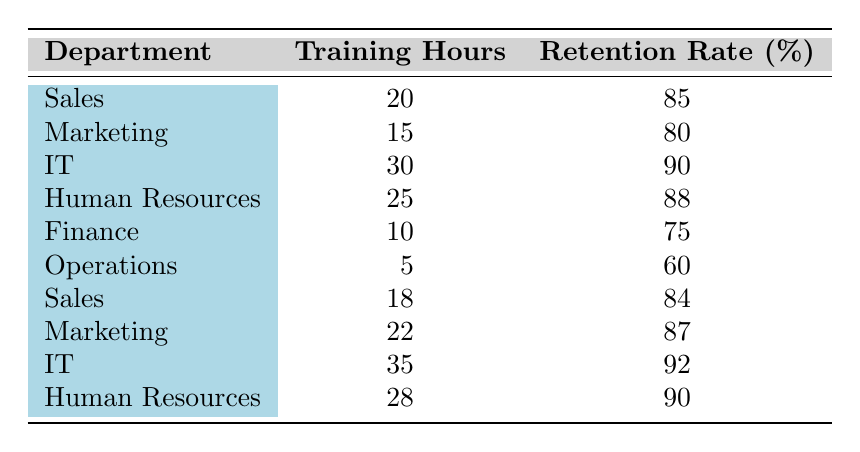What is the retention rate for the IT department? The retention rate for the IT department is listed in the table, where two entries show 90% and 92%. Since both apply to different training hours, the highest is chosen.
Answer: 92 What is the minimum training hours recorded in the table? The training hours can be observed in each row, with the smallest value appearing under the Operations department where it lists 5 hours.
Answer: 5 Which department has the highest retention rate? To determine this, I compared the retention rates across all departments. The rates were 75, 80, 84, 85, 87, 88, 90, and 92. The highest is 92% from the IT department.
Answer: IT What is the average retention rate for the Sales department? I will first find the entries for the Sales department in the table: 85 and 84. Then, the average is calculated by summing these two values (85 + 84 = 169) and dividing by the number of entries (2), giving an average retention rate of 169/2 = 84.5.
Answer: 84.5 Is there a department with a retention rate lower than 75%? I review the retention rates in the table and find a record of 60% for the Operations department, which is indeed less than 75%.
Answer: Yes What is the total training hours of the Marketing department? Looking specifically at the Marketing department, the entries are 15 and 22. Adding these values together (15 + 22) results in a total of 37 training hours for the Marketing department.
Answer: 37 Which department has more training hours: Human Resources or Finance? The Human Resources department shows training hours of 25, while the Finance department lists 10 hours. Comparing these, Human Resources has more training hours.
Answer: Human Resources What is the difference in retention rates between the highest and the lowest department? The highest retention rate is 92% (IT) and the lowest is 60% (Operations). The difference is calculated as 92 - 60, which is 32%.
Answer: 32 How many departments have a retention rate greater than 85%? By examining the table, I count the departments with rates greater than 85% which are IT (90, 92), Human Resources (88), and Marketing (87). There are four such departments: IT (both entries), Human Resources, and Marketing.
Answer: 4 